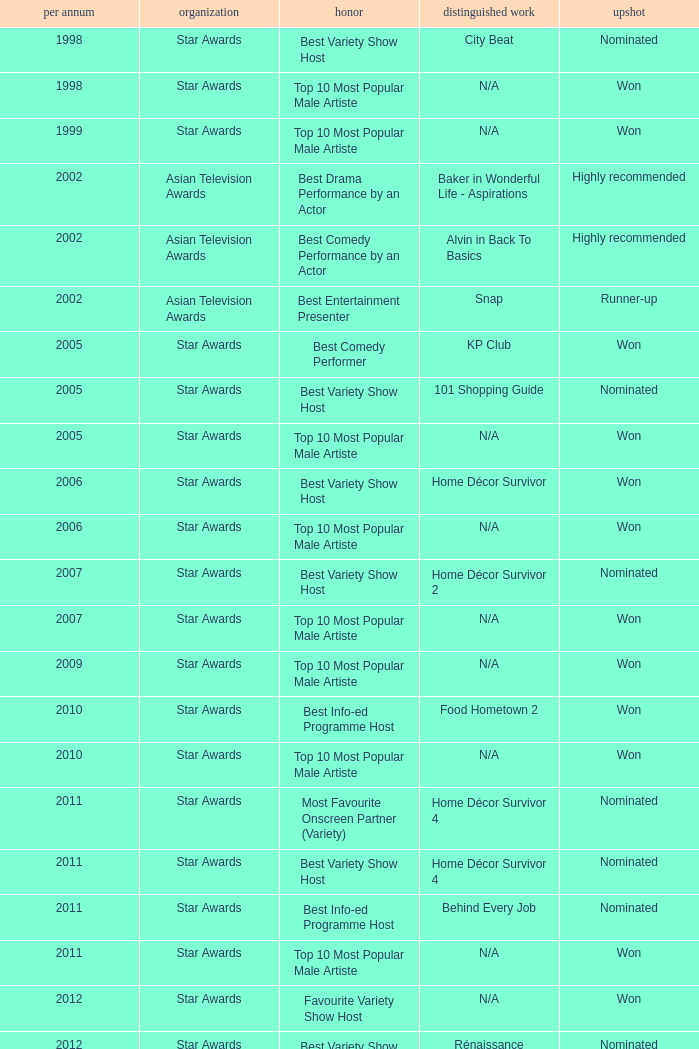What is the award for 1998 with Representative Work of city beat? Best Variety Show Host. 